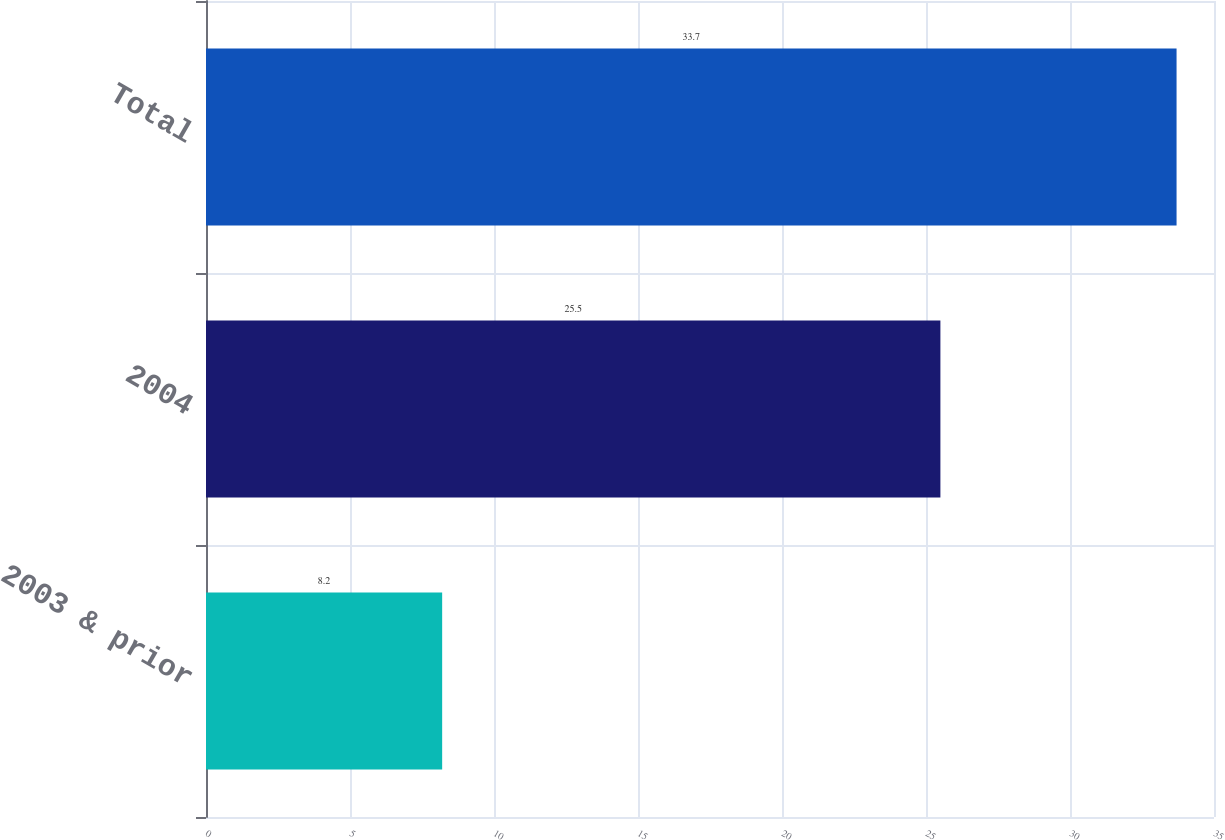Convert chart. <chart><loc_0><loc_0><loc_500><loc_500><bar_chart><fcel>2003 & prior<fcel>2004<fcel>Total<nl><fcel>8.2<fcel>25.5<fcel>33.7<nl></chart> 